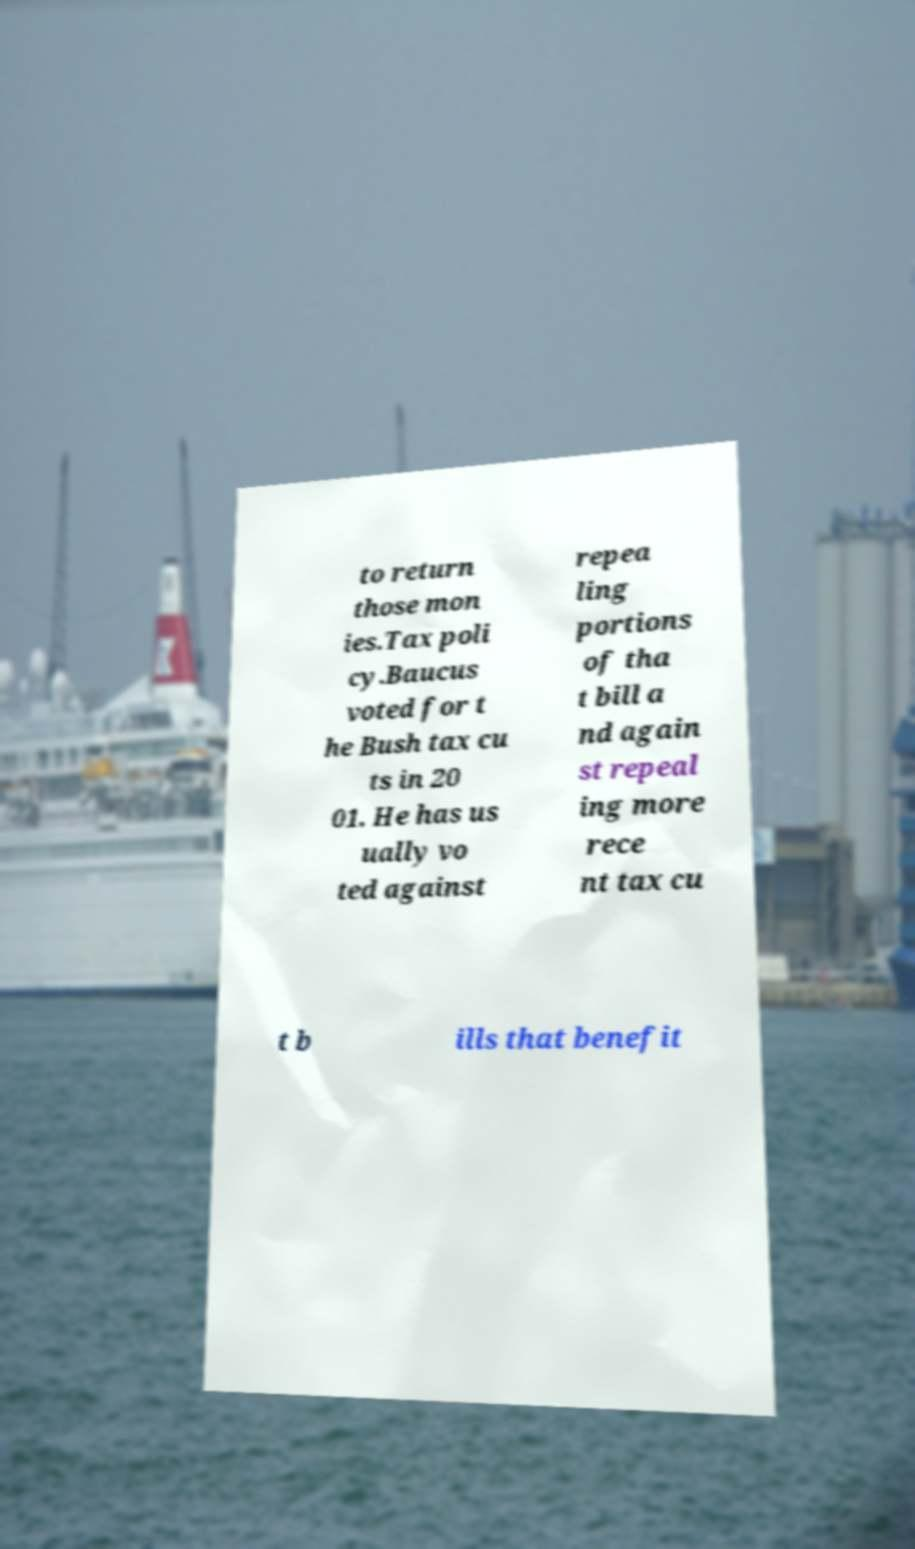Could you assist in decoding the text presented in this image and type it out clearly? to return those mon ies.Tax poli cy.Baucus voted for t he Bush tax cu ts in 20 01. He has us ually vo ted against repea ling portions of tha t bill a nd again st repeal ing more rece nt tax cu t b ills that benefit 